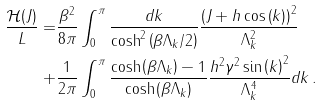<formula> <loc_0><loc_0><loc_500><loc_500>\frac { \mathcal { H } ( J ) } { L } = & \frac { \beta ^ { 2 } } { 8 \pi } \int _ { 0 } ^ { \pi } \frac { d k } { \cosh ^ { 2 } \left ( \beta \Lambda _ { k } / 2 \right ) } \frac { \left ( J + h \cos \left ( k \right ) \right ) ^ { 2 } } { \Lambda _ { k } ^ { 2 } } \\ + & \frac { 1 } { 2 \pi } \int _ { 0 } ^ { \pi } \frac { \cosh \left ( \beta \Lambda _ { k } \right ) - 1 } { \cosh \left ( \beta \Lambda _ { k } \right ) } \frac { h ^ { 2 } \gamma ^ { 2 } \sin \left ( k \right ) ^ { 2 } } { \Lambda _ { k } ^ { 4 } } d k \, .</formula> 